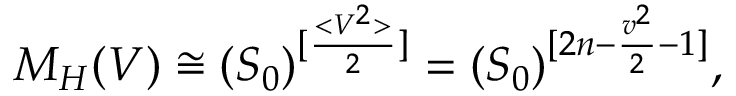Convert formula to latex. <formula><loc_0><loc_0><loc_500><loc_500>M _ { H } ( V ) \cong ( S _ { 0 } ) ^ { [ \frac { < V ^ { 2 } > } { 2 } ] } = ( S _ { 0 } ) ^ { [ 2 n - \frac { v ^ { 2 } } { 2 } - 1 ] } ,</formula> 